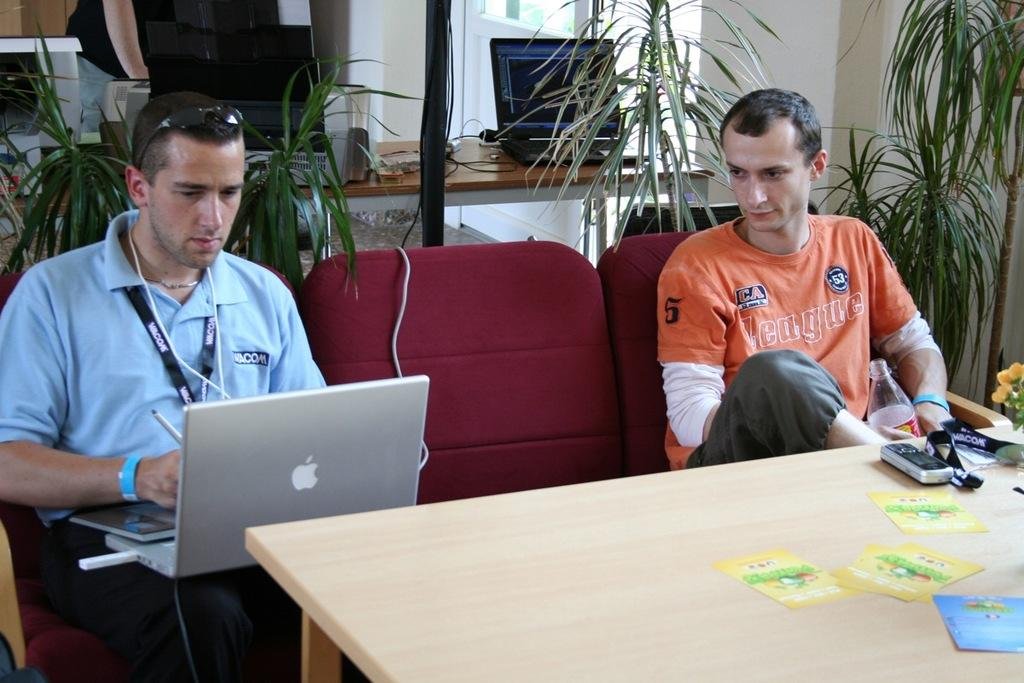How many men are seated in the image? There are two men seated on chairs in the image. What are the seated men doing? The seated men are working on a laptop in the image. What can be seen in the background of the image? There are plants visible in the background of the image. What is in front of the seated men? There is a table in front of the seated men. What type of punishment is being administered to the man working on the laptop in the image? There is no punishment being administered in the image; the man is simply working on a laptop. How many friends are present in the image? The provided facts do not mention any friends in the image, so we cannot determine the number of friends present. 